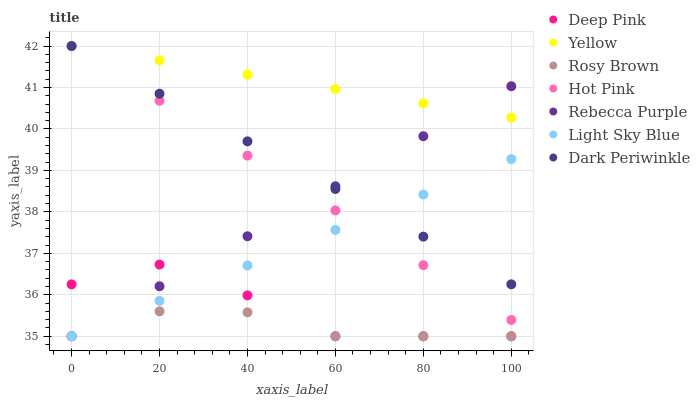Does Rosy Brown have the minimum area under the curve?
Answer yes or no. Yes. Does Yellow have the maximum area under the curve?
Answer yes or no. Yes. Does Yellow have the minimum area under the curve?
Answer yes or no. No. Does Rosy Brown have the maximum area under the curve?
Answer yes or no. No. Is Yellow the smoothest?
Answer yes or no. Yes. Is Deep Pink the roughest?
Answer yes or no. Yes. Is Rosy Brown the smoothest?
Answer yes or no. No. Is Rosy Brown the roughest?
Answer yes or no. No. Does Deep Pink have the lowest value?
Answer yes or no. Yes. Does Yellow have the lowest value?
Answer yes or no. No. Does Dark Periwinkle have the highest value?
Answer yes or no. Yes. Does Rosy Brown have the highest value?
Answer yes or no. No. Is Light Sky Blue less than Yellow?
Answer yes or no. Yes. Is Dark Periwinkle greater than Deep Pink?
Answer yes or no. Yes. Does Dark Periwinkle intersect Rebecca Purple?
Answer yes or no. Yes. Is Dark Periwinkle less than Rebecca Purple?
Answer yes or no. No. Is Dark Periwinkle greater than Rebecca Purple?
Answer yes or no. No. Does Light Sky Blue intersect Yellow?
Answer yes or no. No. 